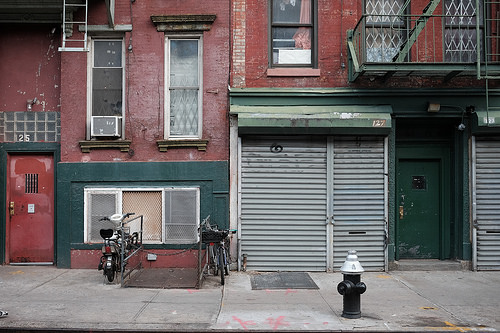<image>
Is there a bicycle in front of the door? No. The bicycle is not in front of the door. The spatial positioning shows a different relationship between these objects. 